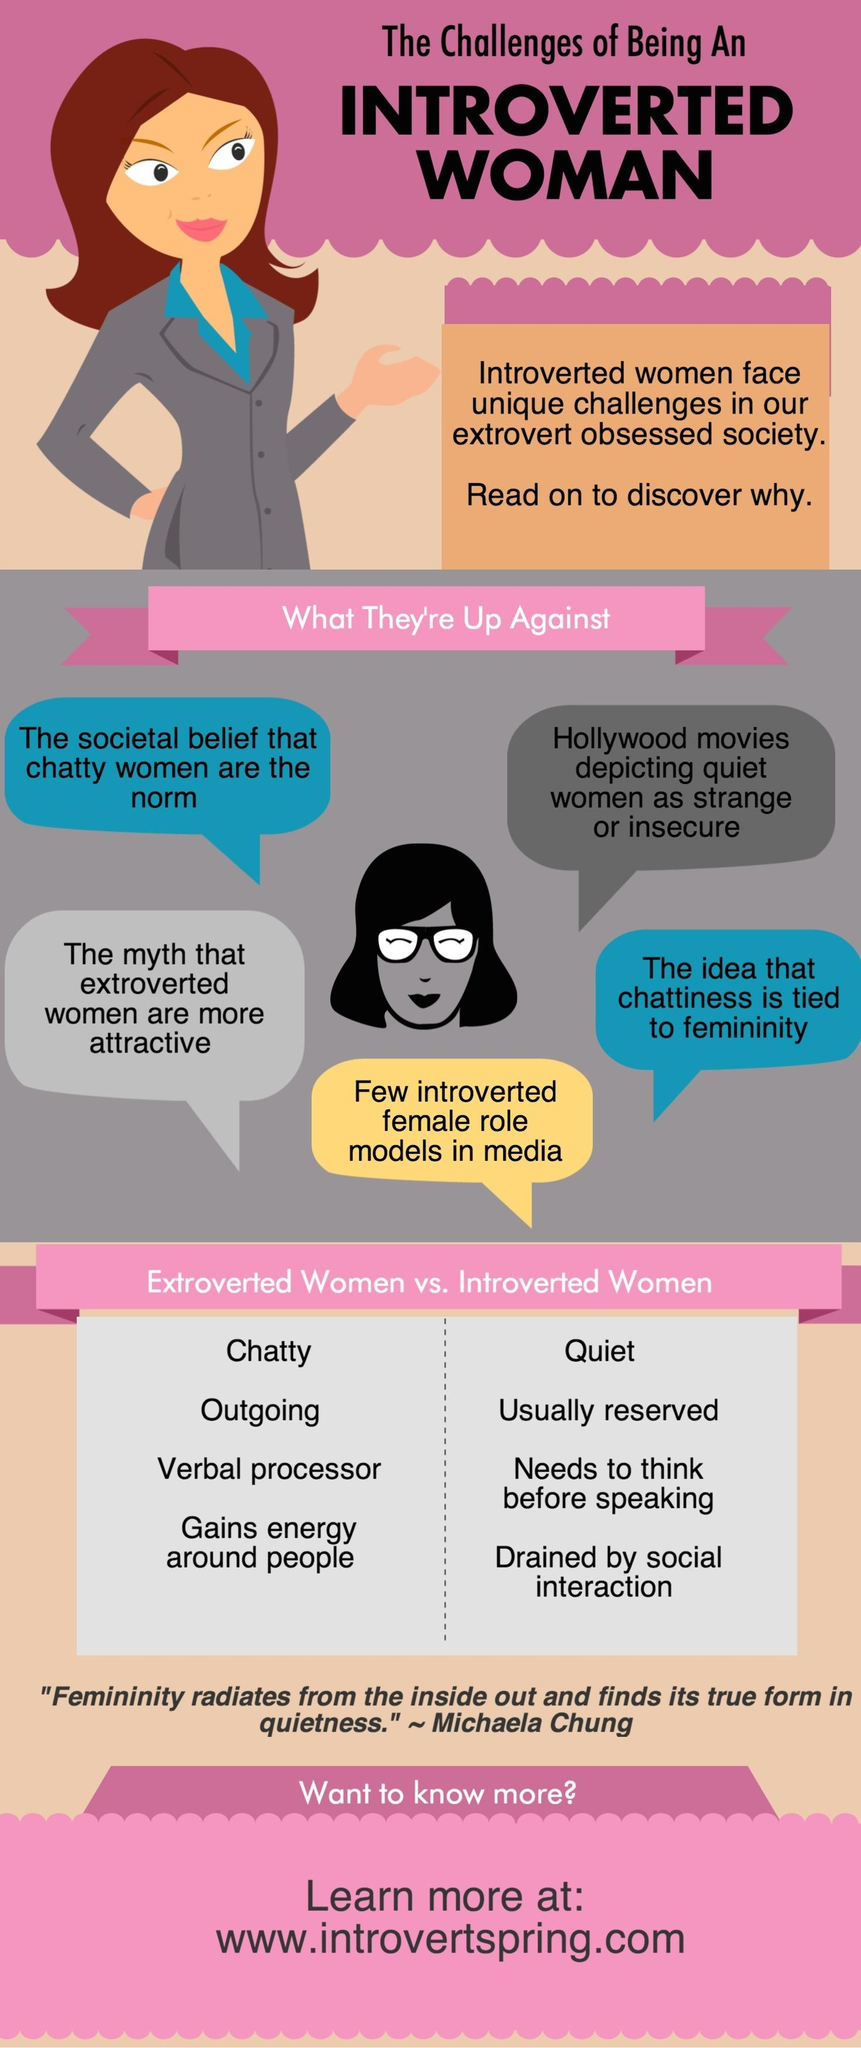Outline some significant characteristics in this image. Chatty, outgoing, and extroverted personalities are typically associated with extroverted women. The infographic contains two difficulties that are highlighted in blue background color. The difficulty faced by an introspective woman, specifically those who are introverted and female, is the lack of representation in media. 